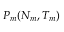<formula> <loc_0><loc_0><loc_500><loc_500>P _ { m } ( N _ { m } , T _ { m } )</formula> 